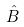<formula> <loc_0><loc_0><loc_500><loc_500>\hat { B }</formula> 